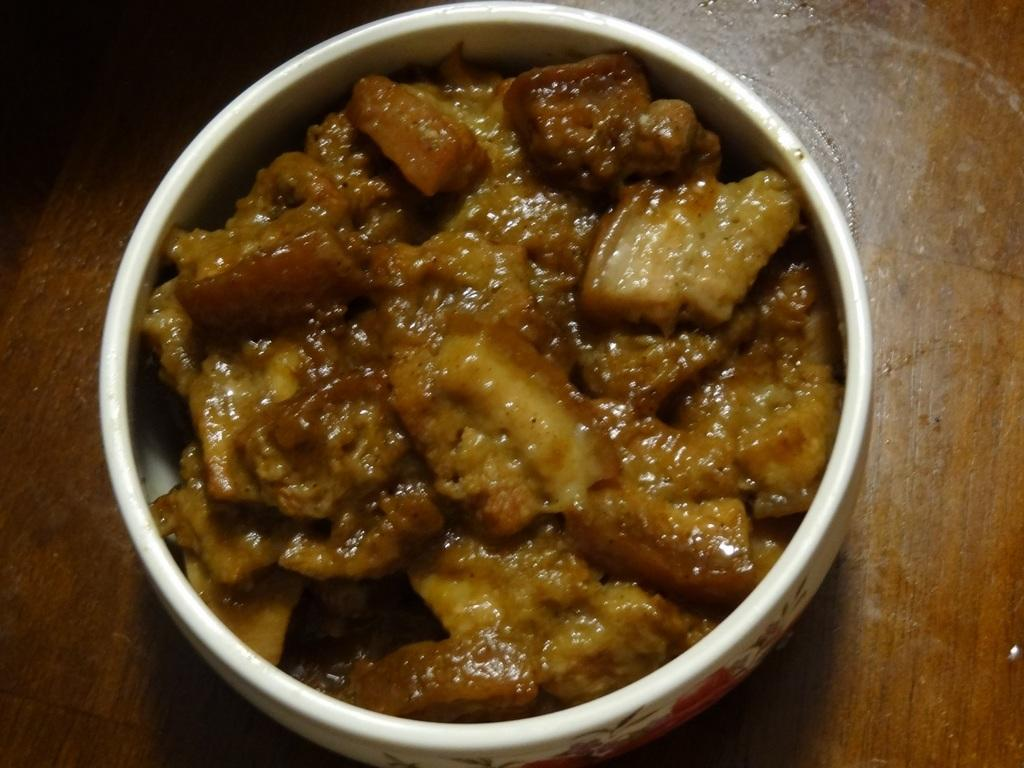What is the color of the box in the image? The box in the image is white. What is inside the box? The box contains food items. On what surface is the box placed? The box is on a wooden surface. Is there a sweater being used as a plate for the food items in the image? No, there is no sweater being used as a plate for the food items in the image. The box contains the food items, and there is no mention of a sweater or plate in the provided facts. 